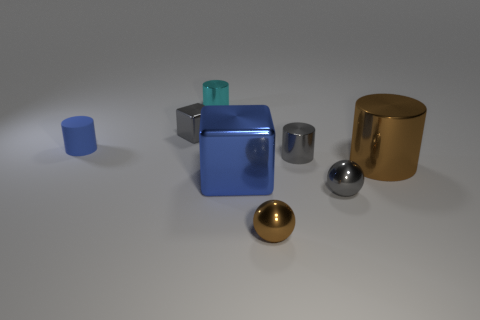How does the light source influence the appearance of the objects on the surface? The light source above the objects produces soft shadows and highlights the reflective properties of the materials. It enhances the three-dimensional quality of the objects, making their shapes and textures more discernible. 